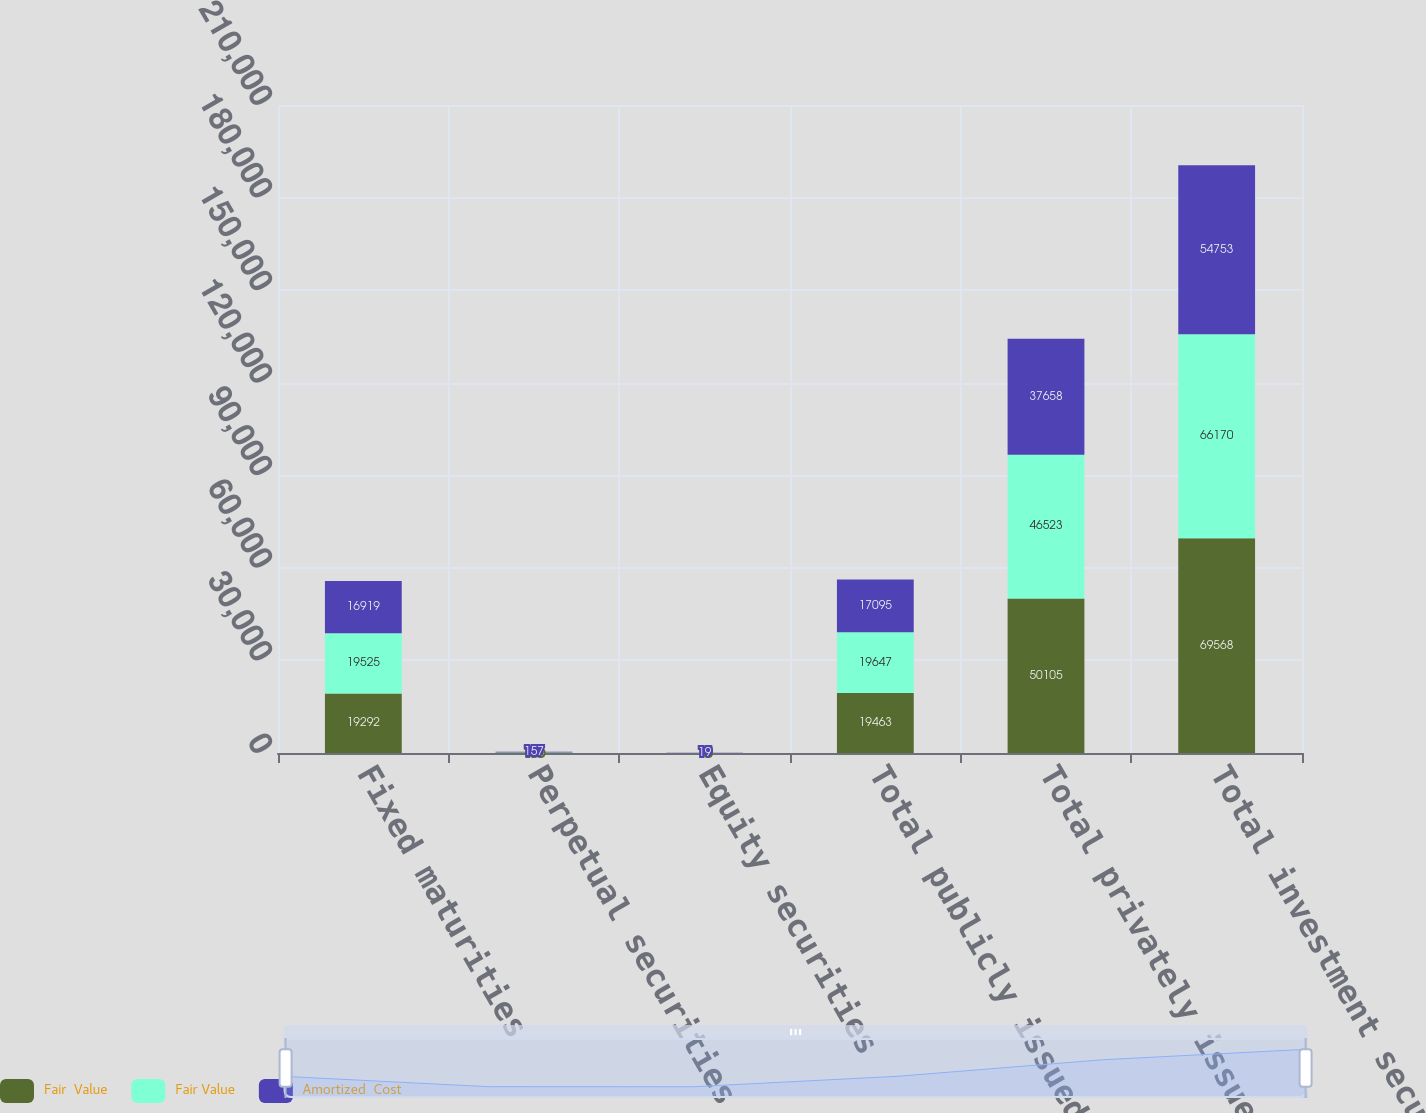<chart> <loc_0><loc_0><loc_500><loc_500><stacked_bar_chart><ecel><fcel>Fixed maturities<fcel>Perpetual securities<fcel>Equity securities<fcel>Total publicly issued<fcel>Total privately issued<fcel>Total investment securities<nl><fcel>Fair  Value<fcel>19292<fcel>156<fcel>15<fcel>19463<fcel>50105<fcel>69568<nl><fcel>Fair Value<fcel>19525<fcel>104<fcel>18<fcel>19647<fcel>46523<fcel>66170<nl><fcel>Amortized  Cost<fcel>16919<fcel>157<fcel>19<fcel>17095<fcel>37658<fcel>54753<nl></chart> 